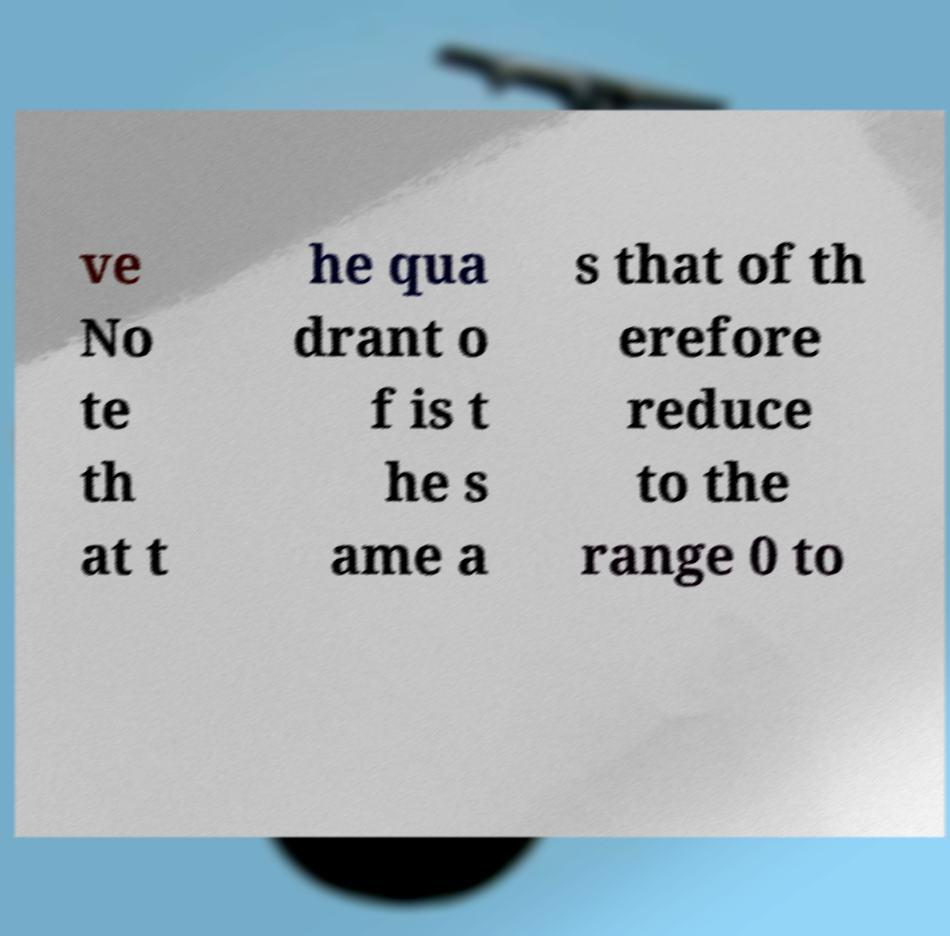Could you extract and type out the text from this image? ve No te th at t he qua drant o f is t he s ame a s that of th erefore reduce to the range 0 to 